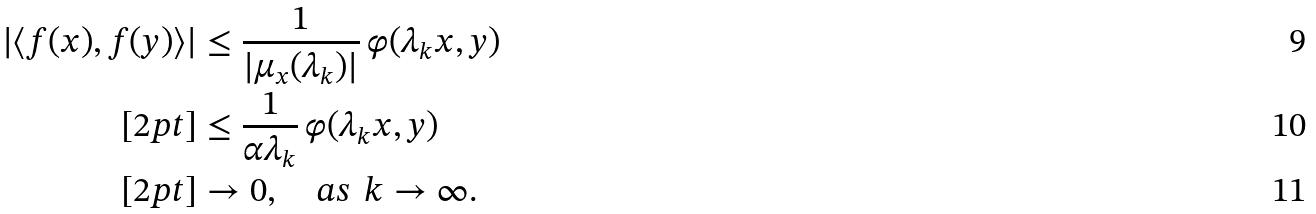Convert formula to latex. <formula><loc_0><loc_0><loc_500><loc_500>| \langle f ( x ) , f ( y ) \rangle | & \leq \frac { 1 } { | \mu _ { x } ( \lambda _ { k } ) | } \, \varphi ( \lambda _ { k } x , y ) \\ [ 2 p t ] & \leq \frac { 1 } { \alpha \lambda _ { k } } \, \varphi ( \lambda _ { k } x , y ) \\ [ 2 p t ] & \to 0 , \quad a s \, \ k \to \infty .</formula> 